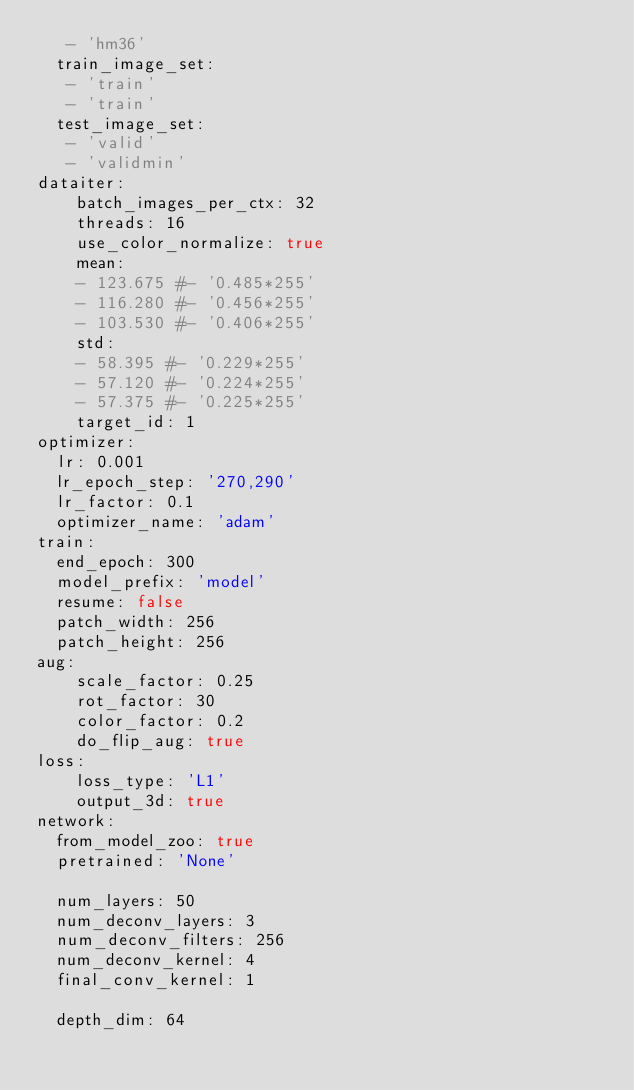<code> <loc_0><loc_0><loc_500><loc_500><_YAML_>   - 'hm36'
  train_image_set:
   - 'train'
   - 'train'
  test_image_set:
   - 'valid'
   - 'validmin'
dataiter:
    batch_images_per_ctx: 32
    threads: 16
    use_color_normalize: true
    mean:
    - 123.675 #- '0.485*255'
    - 116.280 #- '0.456*255'
    - 103.530 #- '0.406*255'
    std:
    - 58.395 #- '0.229*255'
    - 57.120 #- '0.224*255'
    - 57.375 #- '0.225*255'
    target_id: 1
optimizer:
  lr: 0.001
  lr_epoch_step: '270,290'
  lr_factor: 0.1
  optimizer_name: 'adam'
train:
  end_epoch: 300
  model_prefix: 'model'
  resume: false
  patch_width: 256
  patch_height: 256
aug:
    scale_factor: 0.25
    rot_factor: 30
    color_factor: 0.2
    do_flip_aug: true
loss:
    loss_type: 'L1'
    output_3d: true
network:
  from_model_zoo: true
  pretrained: 'None'

  num_layers: 50
  num_deconv_layers: 3
  num_deconv_filters: 256
  num_deconv_kernel: 4
  final_conv_kernel: 1

  depth_dim: 64</code> 